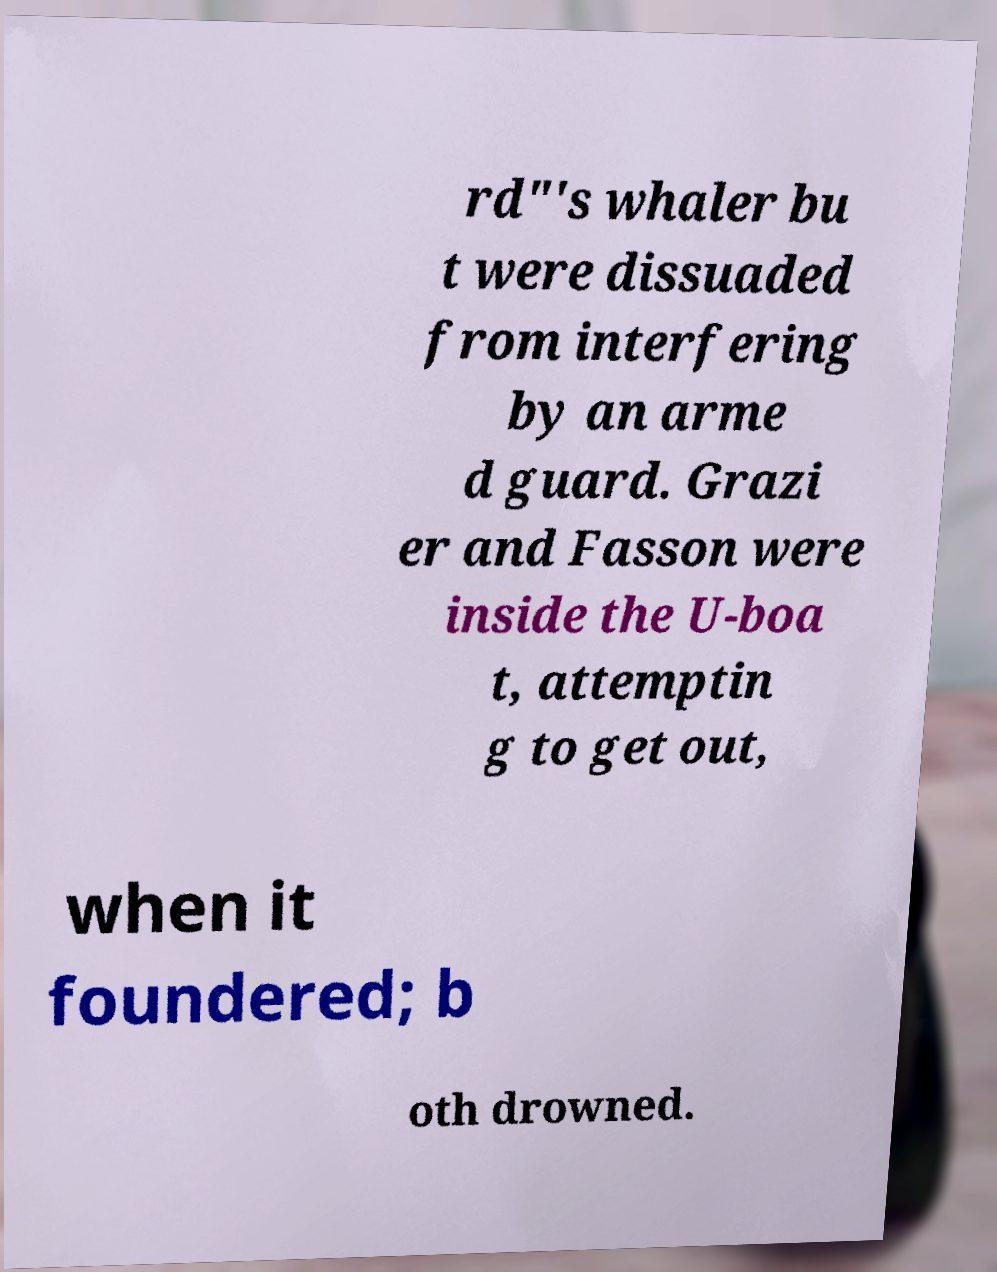Could you extract and type out the text from this image? rd"'s whaler bu t were dissuaded from interfering by an arme d guard. Grazi er and Fasson were inside the U-boa t, attemptin g to get out, when it foundered; b oth drowned. 